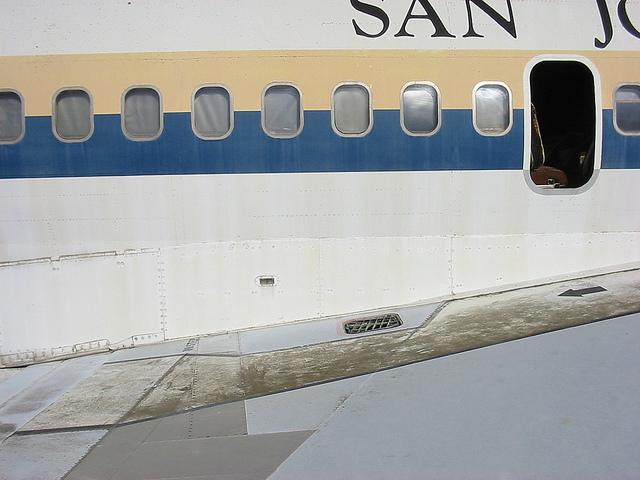Are passengers likely to be loading soon?
Give a very brief answer. No. What is in the picture?
Be succinct. Plane. Is this plane in the air or on the ground?
Write a very short answer. Ground. 